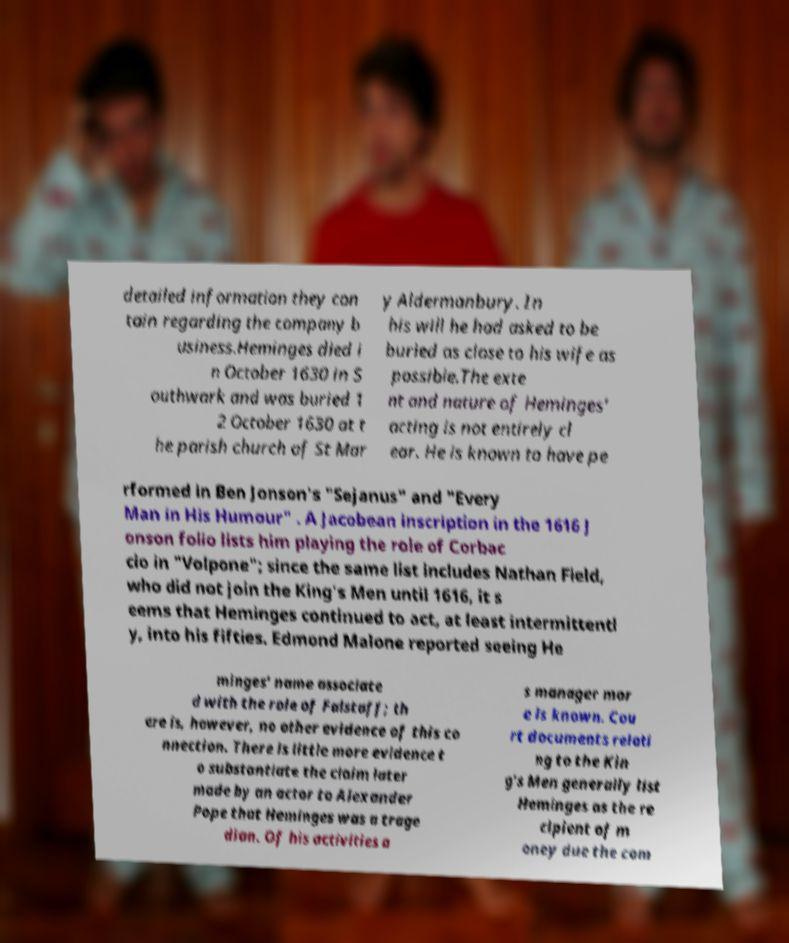For documentation purposes, I need the text within this image transcribed. Could you provide that? detailed information they con tain regarding the company b usiness.Heminges died i n October 1630 in S outhwark and was buried 1 2 October 1630 at t he parish church of St Mar y Aldermanbury. In his will he had asked to be buried as close to his wife as possible.The exte nt and nature of Heminges' acting is not entirely cl ear. He is known to have pe rformed in Ben Jonson's "Sejanus" and "Every Man in His Humour" . A Jacobean inscription in the 1616 J onson folio lists him playing the role of Corbac cio in "Volpone"; since the same list includes Nathan Field, who did not join the King's Men until 1616, it s eems that Heminges continued to act, at least intermittentl y, into his fifties. Edmond Malone reported seeing He minges' name associate d with the role of Falstaff; th ere is, however, no other evidence of this co nnection. There is little more evidence t o substantiate the claim later made by an actor to Alexander Pope that Heminges was a trage dian. Of his activities a s manager mor e is known. Cou rt documents relati ng to the Kin g's Men generally list Heminges as the re cipient of m oney due the com 